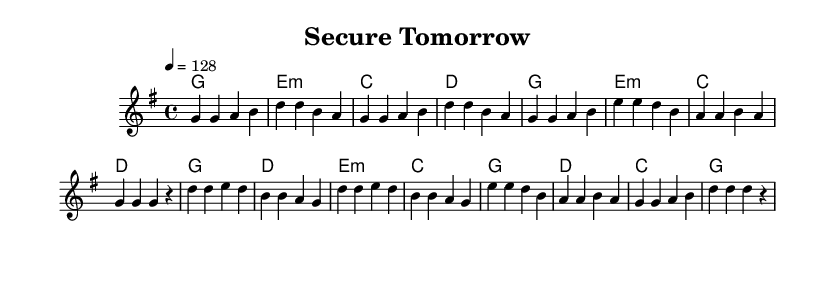What is the key signature of this music? The key signature is G major, which has one sharp (F#).
Answer: G major What is the time signature of this music? The time signature is 4/4, indicating four beats per measure with a quarter note receiving one beat.
Answer: 4/4 What is the tempo marking for this piece? The tempo marking is 128 beats per minute, shown as 4 = 128.
Answer: 128 What harmonies are used in the chorus? The chord progression in the chorus includes G, D, E minor, and C.
Answer: G, D, E minor, C How many measures are there in the verse section? The verse section consists of eight measures.
Answer: Eight Which section features the melodic line that repeats the note 'g'? The verse section contains multiple occurrences of the note 'g'.
Answer: Verse What is the overall theme suggested by the title "Secure Tomorrow"? The title suggests themes of financial security and planning for the future.
Answer: Financial security 